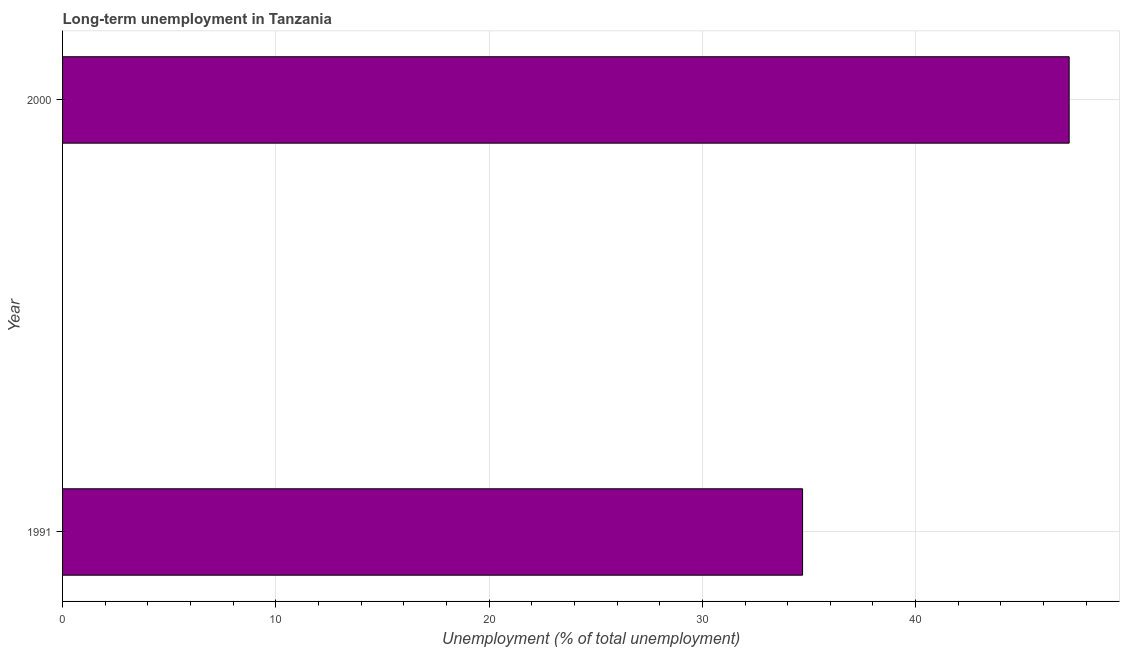Does the graph contain any zero values?
Your answer should be compact. No. Does the graph contain grids?
Provide a short and direct response. Yes. What is the title of the graph?
Offer a very short reply. Long-term unemployment in Tanzania. What is the label or title of the X-axis?
Provide a short and direct response. Unemployment (% of total unemployment). What is the long-term unemployment in 1991?
Keep it short and to the point. 34.7. Across all years, what is the maximum long-term unemployment?
Offer a terse response. 47.2. Across all years, what is the minimum long-term unemployment?
Give a very brief answer. 34.7. In which year was the long-term unemployment maximum?
Provide a short and direct response. 2000. What is the sum of the long-term unemployment?
Offer a very short reply. 81.9. What is the difference between the long-term unemployment in 1991 and 2000?
Ensure brevity in your answer.  -12.5. What is the average long-term unemployment per year?
Offer a terse response. 40.95. What is the median long-term unemployment?
Your answer should be very brief. 40.95. In how many years, is the long-term unemployment greater than 32 %?
Ensure brevity in your answer.  2. What is the ratio of the long-term unemployment in 1991 to that in 2000?
Offer a terse response. 0.73. Is the long-term unemployment in 1991 less than that in 2000?
Offer a very short reply. Yes. Are all the bars in the graph horizontal?
Give a very brief answer. Yes. How many years are there in the graph?
Offer a terse response. 2. What is the difference between two consecutive major ticks on the X-axis?
Provide a succinct answer. 10. Are the values on the major ticks of X-axis written in scientific E-notation?
Offer a terse response. No. What is the Unemployment (% of total unemployment) of 1991?
Provide a succinct answer. 34.7. What is the Unemployment (% of total unemployment) of 2000?
Keep it short and to the point. 47.2. What is the ratio of the Unemployment (% of total unemployment) in 1991 to that in 2000?
Provide a short and direct response. 0.73. 